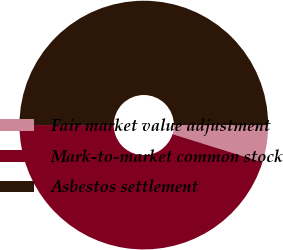Convert chart. <chart><loc_0><loc_0><loc_500><loc_500><pie_chart><fcel>Fair market value adjustment<fcel>Mark-to-market common stock<fcel>Asbestos settlement<nl><fcel>4.82%<fcel>45.18%<fcel>50.0%<nl></chart> 